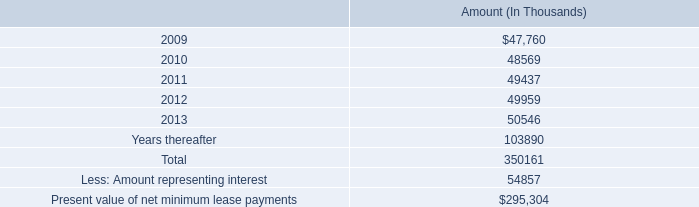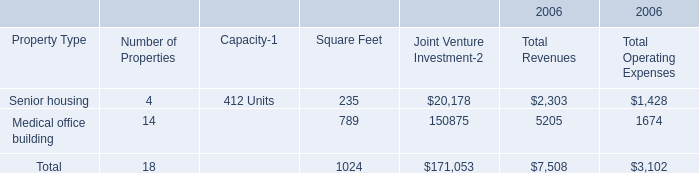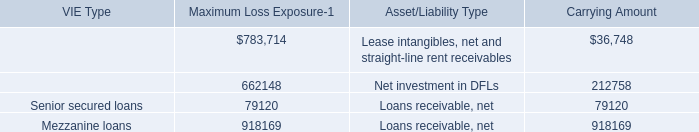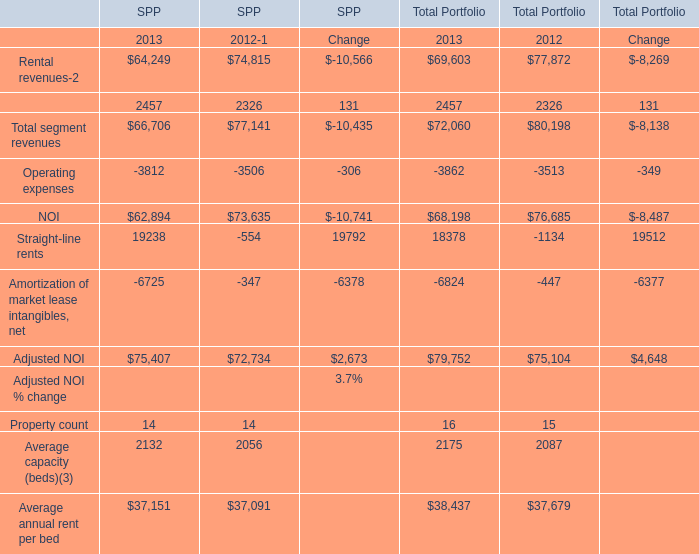In which section the sum of NOI for Total Portfolio has the highest value? 
Answer: 2012. 